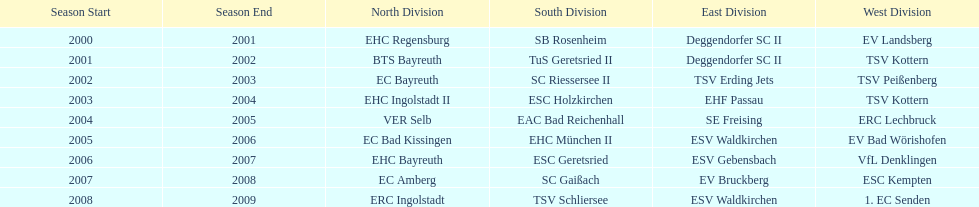The only team to win the north in 2000-01 season? EHC Regensburg. Would you be able to parse every entry in this table? {'header': ['Season Start', 'Season End', 'North Division', 'South Division', 'East Division', 'West Division'], 'rows': [['2000', '2001', 'EHC Regensburg', 'SB Rosenheim', 'Deggendorfer SC II', 'EV Landsberg'], ['2001', '2002', 'BTS Bayreuth', 'TuS Geretsried II', 'Deggendorfer SC II', 'TSV Kottern'], ['2002', '2003', 'EC Bayreuth', 'SC Riessersee II', 'TSV Erding Jets', 'TSV Peißenberg'], ['2003', '2004', 'EHC Ingolstadt II', 'ESC Holzkirchen', 'EHF Passau', 'TSV Kottern'], ['2004', '2005', 'VER Selb', 'EAC Bad Reichenhall', 'SE Freising', 'ERC Lechbruck'], ['2005', '2006', 'EC Bad Kissingen', 'EHC München II', 'ESV Waldkirchen', 'EV Bad Wörishofen'], ['2006', '2007', 'EHC Bayreuth', 'ESC Geretsried', 'ESV Gebensbach', 'VfL Denklingen'], ['2007', '2008', 'EC Amberg', 'SC Gaißach', 'EV Bruckberg', 'ESC Kempten'], ['2008', '2009', 'ERC Ingolstadt', 'TSV Schliersee', 'ESV Waldkirchen', '1. EC Senden']]} 